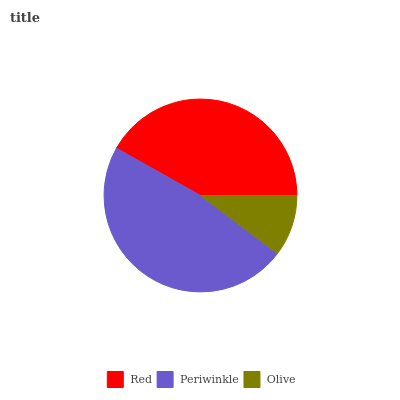Is Olive the minimum?
Answer yes or no. Yes. Is Periwinkle the maximum?
Answer yes or no. Yes. Is Periwinkle the minimum?
Answer yes or no. No. Is Olive the maximum?
Answer yes or no. No. Is Periwinkle greater than Olive?
Answer yes or no. Yes. Is Olive less than Periwinkle?
Answer yes or no. Yes. Is Olive greater than Periwinkle?
Answer yes or no. No. Is Periwinkle less than Olive?
Answer yes or no. No. Is Red the high median?
Answer yes or no. Yes. Is Red the low median?
Answer yes or no. Yes. Is Olive the high median?
Answer yes or no. No. Is Periwinkle the low median?
Answer yes or no. No. 